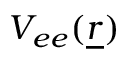<formula> <loc_0><loc_0><loc_500><loc_500>V _ { e e } ( \underline { r } )</formula> 